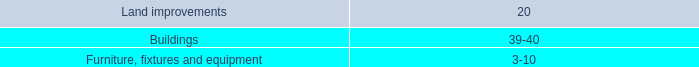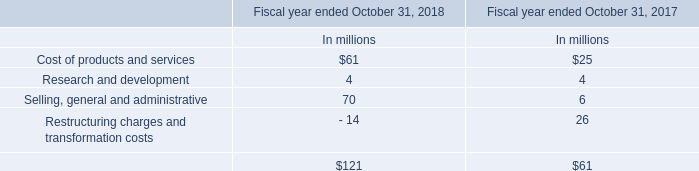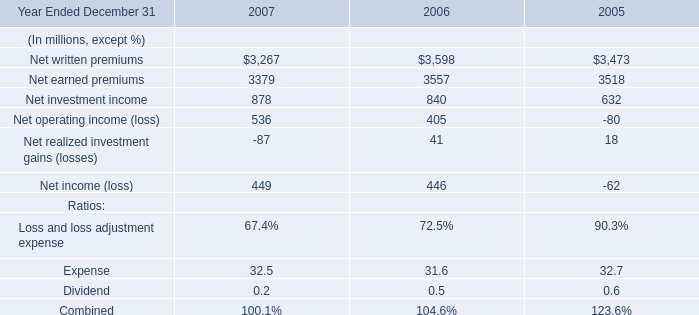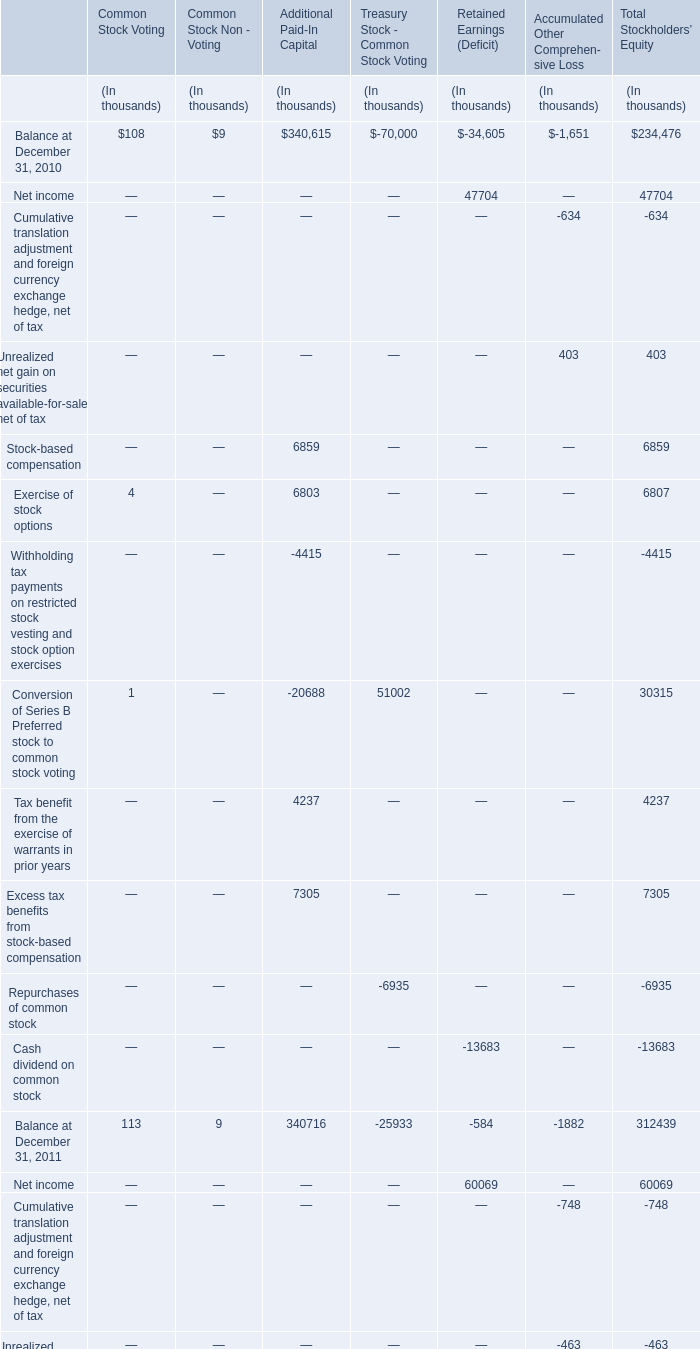what is the percentage change in held-to-maturity securities at cost and at fair value as of january 30 , 2009? 
Computations: ((28.9 - 31.4) / 31.4)
Answer: -0.07962. 